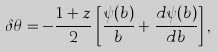Convert formula to latex. <formula><loc_0><loc_0><loc_500><loc_500>\delta \theta = - \frac { 1 + z } { 2 } \left [ \frac { \psi ( b ) } { b } + \frac { d \psi ( b ) } { d b } \right ] ,</formula> 